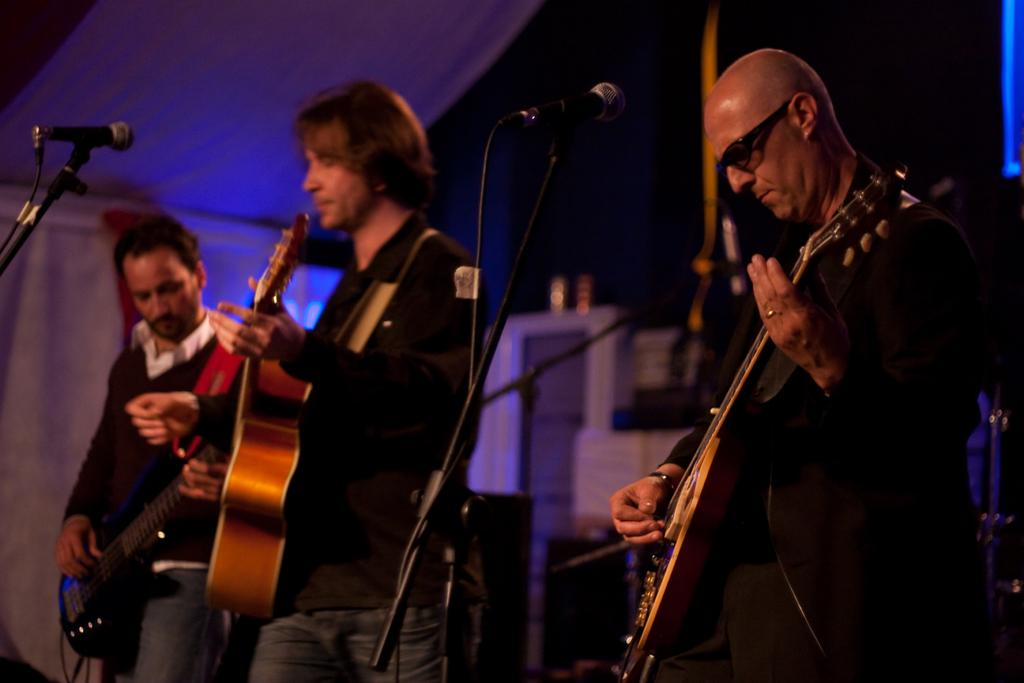How many people are in the image? There are three persons in the image. What are the persons doing in the image? The persons are playing guitar. What objects are in front of the persons? There are microphones in front of them. What color are the dresses of the persons? They are wearing black dress. Where are the persons standing in the image? They appear to be standing under a tent. What is the name of the island where the persons are performing? There is no island mentioned or visible in the image. What holiday are the persons celebrating in the image? There is no indication of a holiday in the image. 